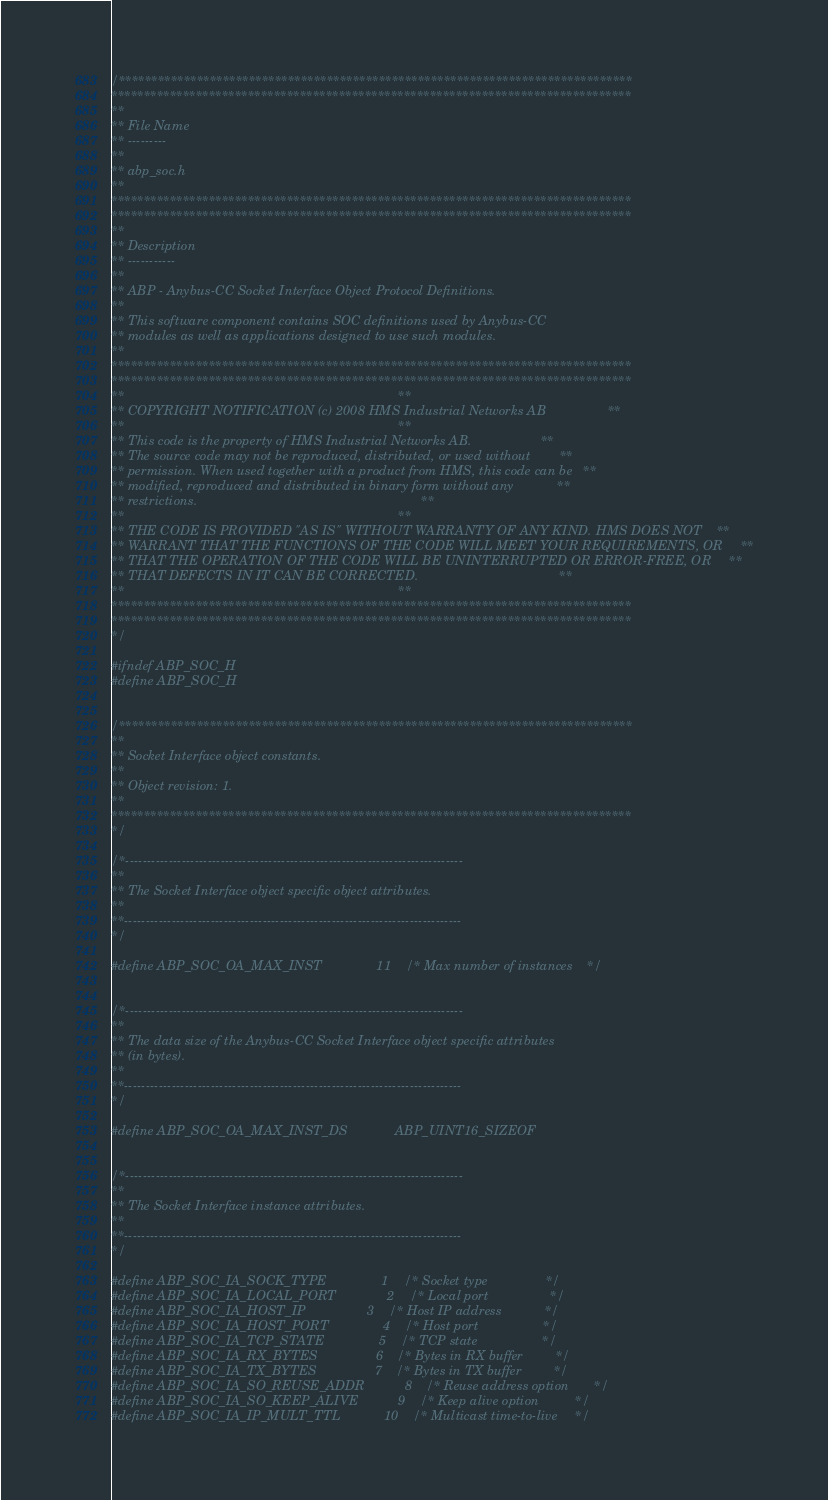Convert code to text. <code><loc_0><loc_0><loc_500><loc_500><_C_>/*******************************************************************************
********************************************************************************
**
** File Name
** ---------
**
** abp_soc.h
**
********************************************************************************
********************************************************************************
**
** Description
** -----------
**
** ABP - Anybus-CC Socket Interface Object Protocol Definitions.
**
** This software component contains SOC definitions used by Anybus-CC
** modules as well as applications designed to use such modules.
**
********************************************************************************
********************************************************************************
**                                                                            **
** COPYRIGHT NOTIFICATION (c) 2008 HMS Industrial Networks AB                 **
**                                                                            **
** This code is the property of HMS Industrial Networks AB.                   **
** The source code may not be reproduced, distributed, or used without        **
** permission. When used together with a product from HMS, this code can be   **
** modified, reproduced and distributed in binary form without any            **
** restrictions.                                                              **
**                                                                            **
** THE CODE IS PROVIDED "AS IS" WITHOUT WARRANTY OF ANY KIND. HMS DOES NOT    **
** WARRANT THAT THE FUNCTIONS OF THE CODE WILL MEET YOUR REQUIREMENTS, OR     **
** THAT THE OPERATION OF THE CODE WILL BE UNINTERRUPTED OR ERROR-FREE, OR     **
** THAT DEFECTS IN IT CAN BE CORRECTED.                                       **
**                                                                            **
********************************************************************************
********************************************************************************
*/

#ifndef ABP_SOC_H
#define ABP_SOC_H


/*******************************************************************************
**
** Socket Interface object constants.
**
** Object revision: 1.
**
********************************************************************************
*/

/*------------------------------------------------------------------------------
**
** The Socket Interface object specific object attributes.
**
**------------------------------------------------------------------------------
*/

#define ABP_SOC_OA_MAX_INST               11    /* Max number of instances    */


/*------------------------------------------------------------------------------
**
** The data size of the Anybus-CC Socket Interface object specific attributes
** (in bytes).
**
**------------------------------------------------------------------------------
*/

#define ABP_SOC_OA_MAX_INST_DS             ABP_UINT16_SIZEOF


/*------------------------------------------------------------------------------
**
** The Socket Interface instance attributes.
**
**------------------------------------------------------------------------------
*/

#define ABP_SOC_IA_SOCK_TYPE               1    /* Socket type                */
#define ABP_SOC_IA_LOCAL_PORT              2    /* Local port                 */
#define ABP_SOC_IA_HOST_IP                 3    /* Host IP address            */
#define ABP_SOC_IA_HOST_PORT               4    /* Host port                  */
#define ABP_SOC_IA_TCP_STATE               5    /* TCP state                  */
#define ABP_SOC_IA_RX_BYTES                6    /* Bytes in RX buffer         */
#define ABP_SOC_IA_TX_BYTES                7    /* Bytes in TX buffer         */
#define ABP_SOC_IA_SO_REUSE_ADDR           8    /* Reuse address option       */
#define ABP_SOC_IA_SO_KEEP_ALIVE           9    /* Keep alive option          */
#define ABP_SOC_IA_IP_MULT_TTL            10    /* Multicast time-to-live     */</code> 